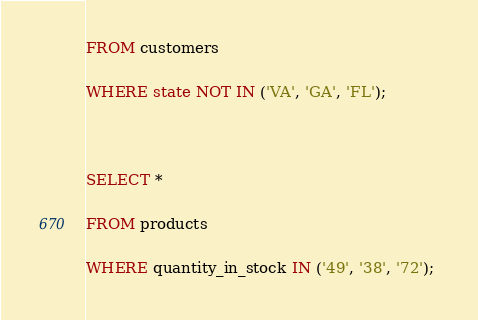<code> <loc_0><loc_0><loc_500><loc_500><_SQL_>FROM customers 

WHERE state NOT IN ('VA', 'GA', 'FL'); 

  

SELECT * 

FROM products 

WHERE quantity_in_stock IN ('49', '38', '72'); 
</code> 